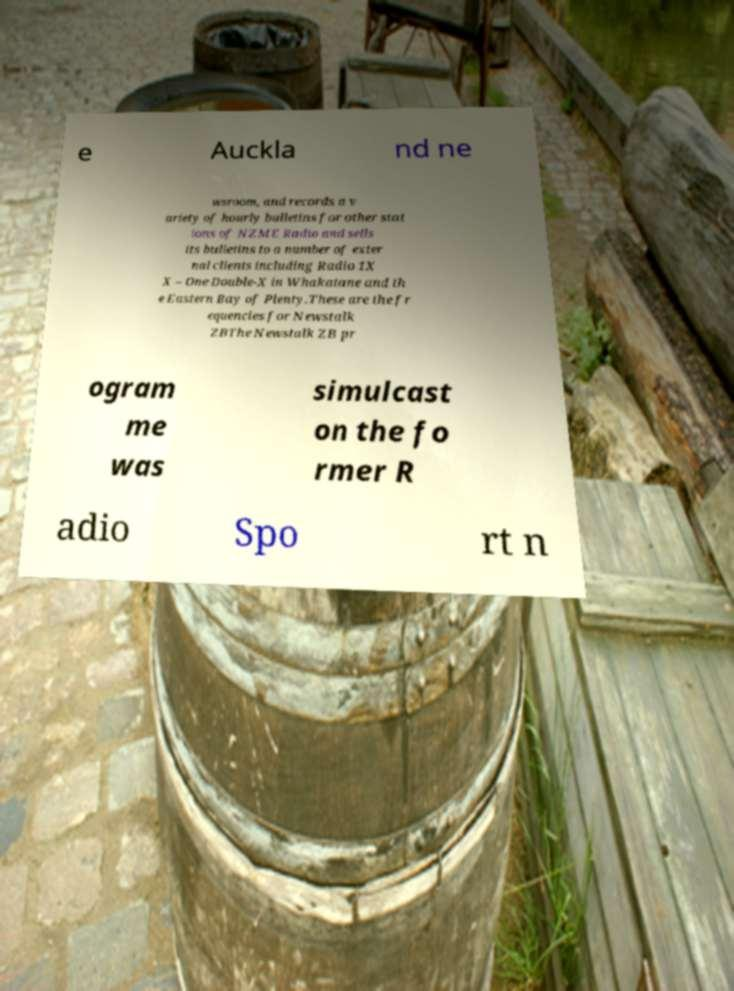Can you accurately transcribe the text from the provided image for me? e Auckla nd ne wsroom, and records a v ariety of hourly bulletins for other stat ions of NZME Radio and sells its bulletins to a number of exter nal clients including Radio 1X X – One Double-X in Whakatane and th e Eastern Bay of Plenty.These are the fr equencies for Newstalk ZBThe Newstalk ZB pr ogram me was simulcast on the fo rmer R adio Spo rt n 